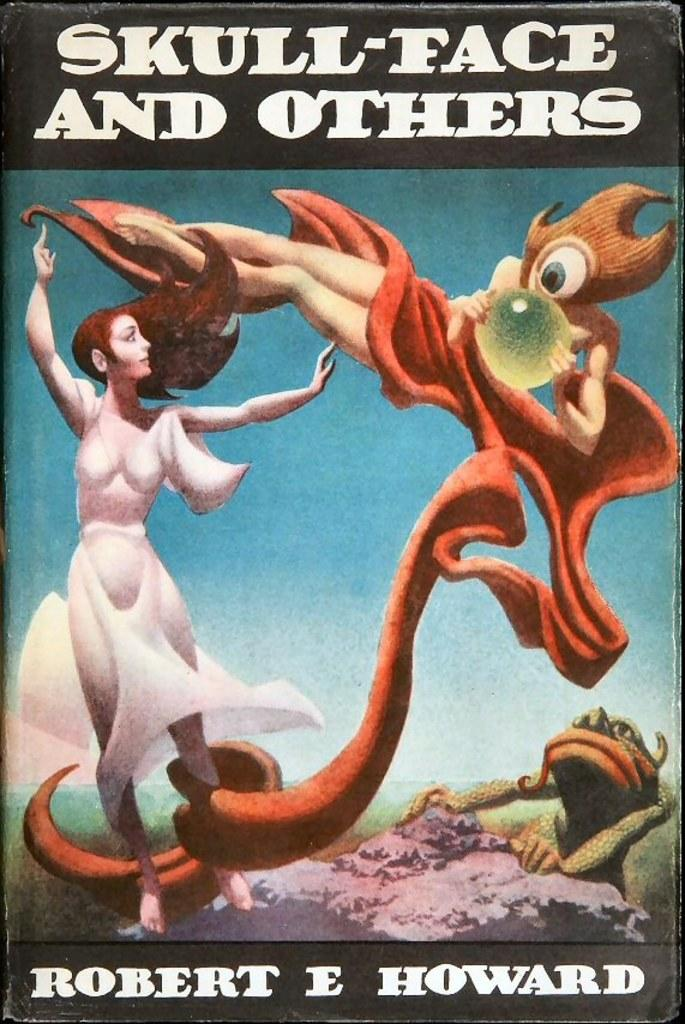<image>
Describe the image concisely. A book called Skull-face and Others has two monsters on the cover. 